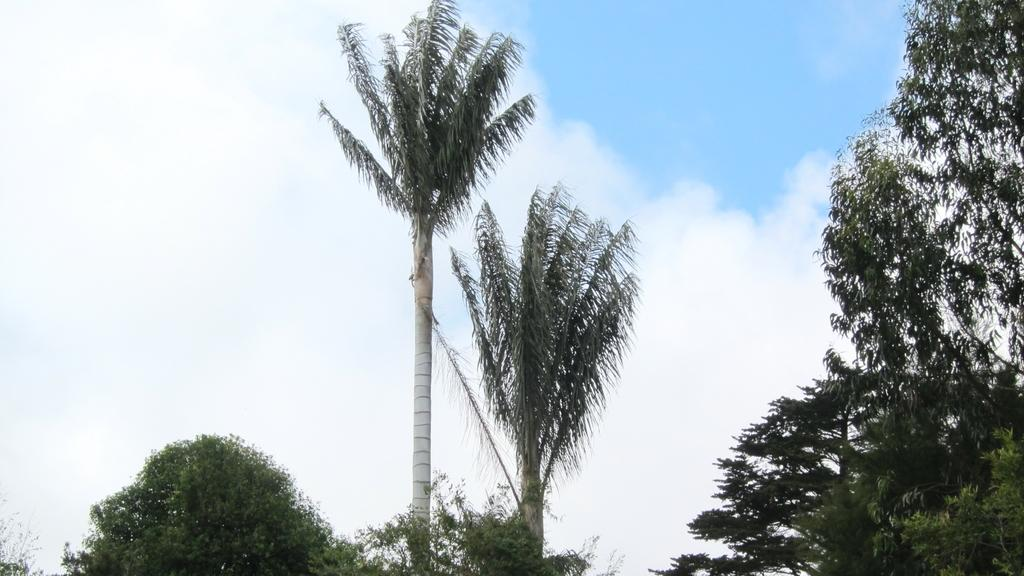What type of vegetation can be seen in the image? There are trees in the image. How would you describe the sky in the image? The sky is cloudy and pale blue in the image. What type of jam is being spread on the airplane in the image? There is no airplane or jam present in the image; it only features trees and a cloudy, pale blue sky. 